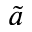<formula> <loc_0><loc_0><loc_500><loc_500>\tilde { a }</formula> 